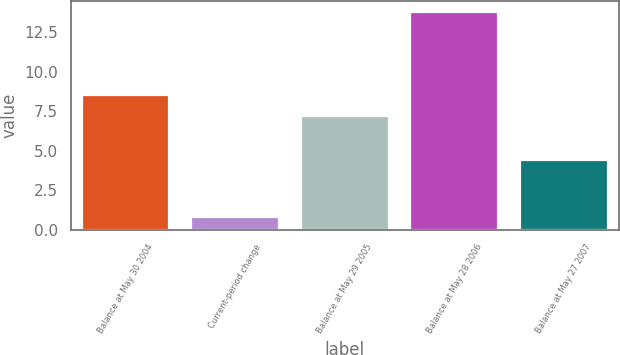Convert chart to OTSL. <chart><loc_0><loc_0><loc_500><loc_500><bar_chart><fcel>Balance at May 30 2004<fcel>Current-period change<fcel>Balance at May 29 2005<fcel>Balance at May 28 2006<fcel>Balance at May 27 2007<nl><fcel>8.5<fcel>0.8<fcel>7.2<fcel>13.8<fcel>4.4<nl></chart> 